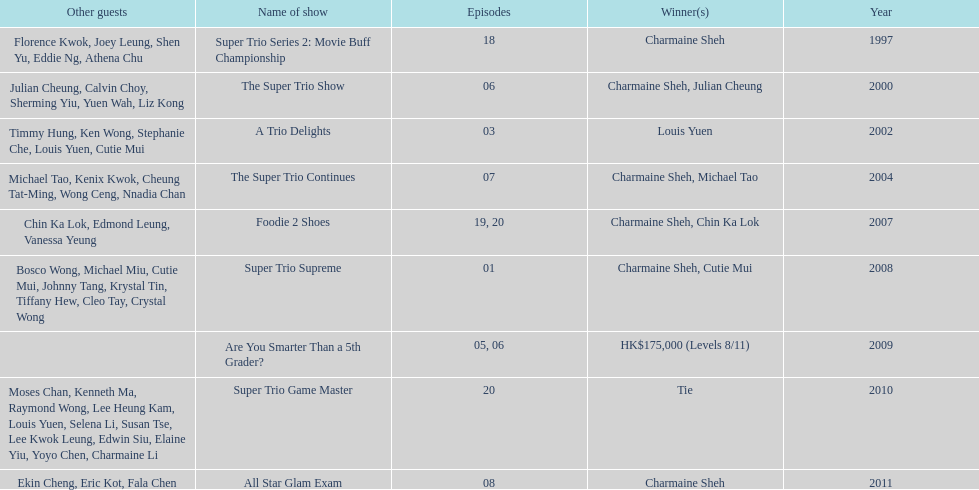How many consecutive trio shows did charmaine sheh do before being on another variety program? 34. 